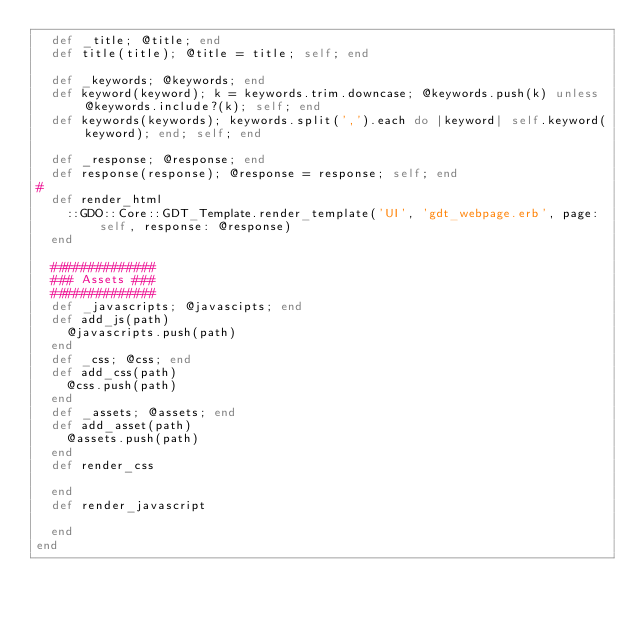Convert code to text. <code><loc_0><loc_0><loc_500><loc_500><_Ruby_>  def _title; @title; end
  def title(title); @title = title; self; end
  
  def _keywords; @keywords; end
  def keyword(keyword); k = keywords.trim.downcase; @keywords.push(k) unless @keywords.include?(k); self; end
  def keywords(keywords); keywords.split(',').each do |keyword| self.keyword(keyword); end; self; end
  
  def _response; @response; end
  def response(response); @response = response; self; end
#   
  def render_html
    ::GDO::Core::GDT_Template.render_template('UI', 'gdt_webpage.erb', page: self, response: @response)
  end

  ##############
  ### Assets ###
  ##############
  def _javascripts; @javascipts; end
  def add_js(path)
    @javascripts.push(path)
  end
  def _css; @css; end
  def add_css(path)
    @css.push(path)
  end
  def _assets; @assets; end
  def add_asset(path)
    @assets.push(path)
  end
  def render_css
    
  end
  def render_javascript
    
  end
end
</code> 